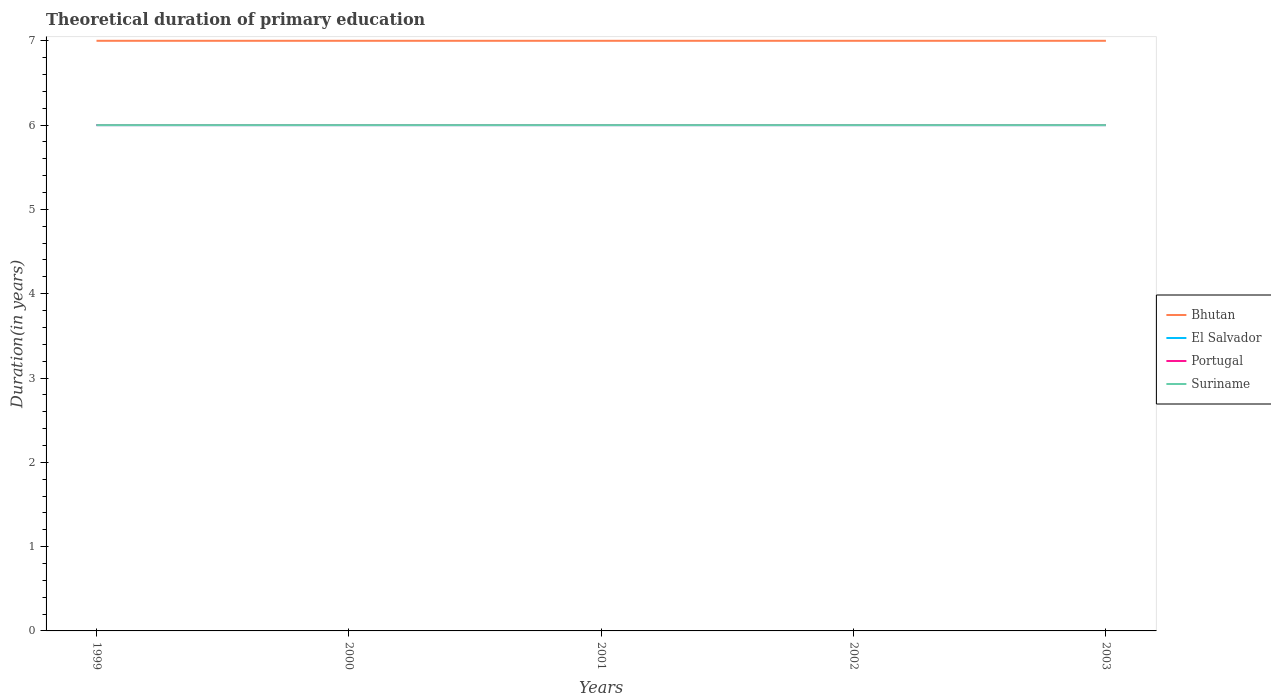How many different coloured lines are there?
Ensure brevity in your answer.  4. Does the line corresponding to Bhutan intersect with the line corresponding to Portugal?
Your answer should be very brief. No. Is the number of lines equal to the number of legend labels?
Give a very brief answer. Yes. What is the difference between the highest and the second highest total theoretical duration of primary education in El Salvador?
Ensure brevity in your answer.  0. What is the difference between the highest and the lowest total theoretical duration of primary education in El Salvador?
Offer a very short reply. 0. How many lines are there?
Provide a succinct answer. 4. How many years are there in the graph?
Ensure brevity in your answer.  5. Are the values on the major ticks of Y-axis written in scientific E-notation?
Keep it short and to the point. No. Where does the legend appear in the graph?
Your answer should be very brief. Center right. How many legend labels are there?
Give a very brief answer. 4. How are the legend labels stacked?
Your answer should be compact. Vertical. What is the title of the graph?
Provide a succinct answer. Theoretical duration of primary education. What is the label or title of the X-axis?
Provide a short and direct response. Years. What is the label or title of the Y-axis?
Offer a terse response. Duration(in years). What is the Duration(in years) of Bhutan in 1999?
Give a very brief answer. 7. What is the Duration(in years) of El Salvador in 1999?
Keep it short and to the point. 6. What is the Duration(in years) of Portugal in 1999?
Your answer should be very brief. 6. What is the Duration(in years) in Suriname in 1999?
Provide a succinct answer. 6. What is the Duration(in years) of Bhutan in 2000?
Offer a very short reply. 7. What is the Duration(in years) in Bhutan in 2001?
Offer a terse response. 7. What is the Duration(in years) in El Salvador in 2001?
Ensure brevity in your answer.  6. What is the Duration(in years) in Portugal in 2001?
Offer a terse response. 6. What is the Duration(in years) in Suriname in 2001?
Provide a short and direct response. 6. What is the Duration(in years) of Bhutan in 2002?
Ensure brevity in your answer.  7. What is the Duration(in years) of Suriname in 2003?
Give a very brief answer. 6. Across all years, what is the maximum Duration(in years) in Bhutan?
Provide a short and direct response. 7. Across all years, what is the maximum Duration(in years) in Portugal?
Offer a terse response. 6. Across all years, what is the maximum Duration(in years) in Suriname?
Give a very brief answer. 6. Across all years, what is the minimum Duration(in years) of Bhutan?
Offer a very short reply. 7. Across all years, what is the minimum Duration(in years) of Portugal?
Ensure brevity in your answer.  6. What is the total Duration(in years) of El Salvador in the graph?
Give a very brief answer. 30. What is the total Duration(in years) of Suriname in the graph?
Give a very brief answer. 30. What is the difference between the Duration(in years) in Suriname in 1999 and that in 2000?
Your answer should be compact. 0. What is the difference between the Duration(in years) of Portugal in 1999 and that in 2001?
Offer a very short reply. 0. What is the difference between the Duration(in years) in Bhutan in 1999 and that in 2002?
Your answer should be very brief. 0. What is the difference between the Duration(in years) of Bhutan in 1999 and that in 2003?
Your response must be concise. 0. What is the difference between the Duration(in years) of El Salvador in 1999 and that in 2003?
Ensure brevity in your answer.  0. What is the difference between the Duration(in years) in Portugal in 1999 and that in 2003?
Your response must be concise. 0. What is the difference between the Duration(in years) of El Salvador in 2000 and that in 2001?
Provide a short and direct response. 0. What is the difference between the Duration(in years) of Portugal in 2000 and that in 2001?
Your answer should be very brief. 0. What is the difference between the Duration(in years) in Suriname in 2000 and that in 2001?
Offer a very short reply. 0. What is the difference between the Duration(in years) of Bhutan in 2000 and that in 2002?
Provide a short and direct response. 0. What is the difference between the Duration(in years) of Suriname in 2000 and that in 2002?
Ensure brevity in your answer.  0. What is the difference between the Duration(in years) of Portugal in 2000 and that in 2003?
Offer a terse response. 0. What is the difference between the Duration(in years) of Suriname in 2000 and that in 2003?
Make the answer very short. 0. What is the difference between the Duration(in years) in El Salvador in 2001 and that in 2002?
Give a very brief answer. 0. What is the difference between the Duration(in years) in Bhutan in 2001 and that in 2003?
Your answer should be compact. 0. What is the difference between the Duration(in years) in El Salvador in 2001 and that in 2003?
Ensure brevity in your answer.  0. What is the difference between the Duration(in years) of El Salvador in 2002 and that in 2003?
Give a very brief answer. 0. What is the difference between the Duration(in years) in Portugal in 2002 and that in 2003?
Your answer should be compact. 0. What is the difference between the Duration(in years) of Suriname in 2002 and that in 2003?
Provide a short and direct response. 0. What is the difference between the Duration(in years) in Bhutan in 1999 and the Duration(in years) in Suriname in 2000?
Provide a succinct answer. 1. What is the difference between the Duration(in years) in Portugal in 1999 and the Duration(in years) in Suriname in 2000?
Make the answer very short. 0. What is the difference between the Duration(in years) in Bhutan in 1999 and the Duration(in years) in El Salvador in 2001?
Offer a terse response. 1. What is the difference between the Duration(in years) in Bhutan in 1999 and the Duration(in years) in Portugal in 2001?
Keep it short and to the point. 1. What is the difference between the Duration(in years) of Portugal in 1999 and the Duration(in years) of Suriname in 2001?
Make the answer very short. 0. What is the difference between the Duration(in years) of Bhutan in 1999 and the Duration(in years) of El Salvador in 2002?
Your answer should be very brief. 1. What is the difference between the Duration(in years) in Bhutan in 1999 and the Duration(in years) in Suriname in 2002?
Make the answer very short. 1. What is the difference between the Duration(in years) of El Salvador in 1999 and the Duration(in years) of Portugal in 2002?
Your answer should be very brief. 0. What is the difference between the Duration(in years) in El Salvador in 1999 and the Duration(in years) in Suriname in 2002?
Give a very brief answer. 0. What is the difference between the Duration(in years) in Portugal in 1999 and the Duration(in years) in Suriname in 2002?
Offer a very short reply. 0. What is the difference between the Duration(in years) of Bhutan in 1999 and the Duration(in years) of El Salvador in 2003?
Provide a succinct answer. 1. What is the difference between the Duration(in years) of El Salvador in 1999 and the Duration(in years) of Portugal in 2003?
Keep it short and to the point. 0. What is the difference between the Duration(in years) in Bhutan in 2000 and the Duration(in years) in El Salvador in 2001?
Keep it short and to the point. 1. What is the difference between the Duration(in years) in El Salvador in 2000 and the Duration(in years) in Suriname in 2001?
Keep it short and to the point. 0. What is the difference between the Duration(in years) in Bhutan in 2000 and the Duration(in years) in Portugal in 2002?
Give a very brief answer. 1. What is the difference between the Duration(in years) of El Salvador in 2000 and the Duration(in years) of Portugal in 2002?
Your answer should be compact. 0. What is the difference between the Duration(in years) in Portugal in 2000 and the Duration(in years) in Suriname in 2002?
Ensure brevity in your answer.  0. What is the difference between the Duration(in years) in Bhutan in 2000 and the Duration(in years) in El Salvador in 2003?
Give a very brief answer. 1. What is the difference between the Duration(in years) in Bhutan in 2000 and the Duration(in years) in Portugal in 2003?
Ensure brevity in your answer.  1. What is the difference between the Duration(in years) of El Salvador in 2000 and the Duration(in years) of Portugal in 2003?
Give a very brief answer. 0. What is the difference between the Duration(in years) in El Salvador in 2000 and the Duration(in years) in Suriname in 2003?
Your answer should be very brief. 0. What is the difference between the Duration(in years) of Bhutan in 2001 and the Duration(in years) of El Salvador in 2002?
Your answer should be compact. 1. What is the difference between the Duration(in years) of Bhutan in 2001 and the Duration(in years) of Portugal in 2002?
Provide a succinct answer. 1. What is the difference between the Duration(in years) in El Salvador in 2001 and the Duration(in years) in Portugal in 2002?
Give a very brief answer. 0. What is the difference between the Duration(in years) of El Salvador in 2001 and the Duration(in years) of Suriname in 2002?
Your response must be concise. 0. What is the difference between the Duration(in years) in Portugal in 2001 and the Duration(in years) in Suriname in 2002?
Offer a terse response. 0. What is the difference between the Duration(in years) in Bhutan in 2001 and the Duration(in years) in El Salvador in 2003?
Give a very brief answer. 1. What is the difference between the Duration(in years) of El Salvador in 2001 and the Duration(in years) of Portugal in 2003?
Offer a terse response. 0. What is the difference between the Duration(in years) of El Salvador in 2002 and the Duration(in years) of Portugal in 2003?
Your answer should be compact. 0. What is the difference between the Duration(in years) in El Salvador in 2002 and the Duration(in years) in Suriname in 2003?
Offer a very short reply. 0. What is the average Duration(in years) of Bhutan per year?
Give a very brief answer. 7. What is the average Duration(in years) of El Salvador per year?
Offer a very short reply. 6. In the year 1999, what is the difference between the Duration(in years) in El Salvador and Duration(in years) in Portugal?
Provide a short and direct response. 0. In the year 1999, what is the difference between the Duration(in years) in El Salvador and Duration(in years) in Suriname?
Keep it short and to the point. 0. In the year 1999, what is the difference between the Duration(in years) in Portugal and Duration(in years) in Suriname?
Your answer should be compact. 0. In the year 2000, what is the difference between the Duration(in years) in Bhutan and Duration(in years) in Portugal?
Offer a very short reply. 1. In the year 2000, what is the difference between the Duration(in years) of El Salvador and Duration(in years) of Portugal?
Your response must be concise. 0. In the year 2001, what is the difference between the Duration(in years) in Bhutan and Duration(in years) in Portugal?
Keep it short and to the point. 1. In the year 2001, what is the difference between the Duration(in years) in El Salvador and Duration(in years) in Suriname?
Provide a short and direct response. 0. In the year 2001, what is the difference between the Duration(in years) of Portugal and Duration(in years) of Suriname?
Offer a very short reply. 0. In the year 2002, what is the difference between the Duration(in years) in Bhutan and Duration(in years) in Suriname?
Ensure brevity in your answer.  1. In the year 2002, what is the difference between the Duration(in years) in El Salvador and Duration(in years) in Portugal?
Your response must be concise. 0. In the year 2002, what is the difference between the Duration(in years) in El Salvador and Duration(in years) in Suriname?
Your answer should be compact. 0. In the year 2003, what is the difference between the Duration(in years) of Bhutan and Duration(in years) of Portugal?
Ensure brevity in your answer.  1. In the year 2003, what is the difference between the Duration(in years) of El Salvador and Duration(in years) of Portugal?
Your response must be concise. 0. What is the ratio of the Duration(in years) of El Salvador in 1999 to that in 2000?
Provide a short and direct response. 1. What is the ratio of the Duration(in years) of Suriname in 1999 to that in 2001?
Provide a short and direct response. 1. What is the ratio of the Duration(in years) of Portugal in 1999 to that in 2002?
Offer a terse response. 1. What is the ratio of the Duration(in years) of Bhutan in 1999 to that in 2003?
Your answer should be compact. 1. What is the ratio of the Duration(in years) of El Salvador in 1999 to that in 2003?
Provide a succinct answer. 1. What is the ratio of the Duration(in years) in Portugal in 1999 to that in 2003?
Provide a short and direct response. 1. What is the ratio of the Duration(in years) in Suriname in 1999 to that in 2003?
Give a very brief answer. 1. What is the ratio of the Duration(in years) of Bhutan in 2000 to that in 2001?
Your answer should be very brief. 1. What is the ratio of the Duration(in years) of El Salvador in 2000 to that in 2001?
Give a very brief answer. 1. What is the ratio of the Duration(in years) in Portugal in 2000 to that in 2001?
Keep it short and to the point. 1. What is the ratio of the Duration(in years) of Suriname in 2000 to that in 2001?
Give a very brief answer. 1. What is the ratio of the Duration(in years) in El Salvador in 2000 to that in 2002?
Ensure brevity in your answer.  1. What is the ratio of the Duration(in years) of Portugal in 2000 to that in 2002?
Offer a very short reply. 1. What is the ratio of the Duration(in years) in Suriname in 2000 to that in 2002?
Make the answer very short. 1. What is the ratio of the Duration(in years) in Portugal in 2001 to that in 2002?
Keep it short and to the point. 1. What is the ratio of the Duration(in years) of Suriname in 2001 to that in 2002?
Provide a succinct answer. 1. What is the ratio of the Duration(in years) in Bhutan in 2001 to that in 2003?
Offer a very short reply. 1. What is the ratio of the Duration(in years) of El Salvador in 2001 to that in 2003?
Your response must be concise. 1. What is the ratio of the Duration(in years) in Suriname in 2001 to that in 2003?
Your response must be concise. 1. What is the ratio of the Duration(in years) in El Salvador in 2002 to that in 2003?
Offer a very short reply. 1. What is the ratio of the Duration(in years) of Portugal in 2002 to that in 2003?
Your response must be concise. 1. What is the difference between the highest and the second highest Duration(in years) of Bhutan?
Your answer should be compact. 0. What is the difference between the highest and the second highest Duration(in years) in El Salvador?
Your answer should be very brief. 0. What is the difference between the highest and the second highest Duration(in years) of Suriname?
Provide a short and direct response. 0. What is the difference between the highest and the lowest Duration(in years) of El Salvador?
Your answer should be very brief. 0. What is the difference between the highest and the lowest Duration(in years) of Portugal?
Your response must be concise. 0. 